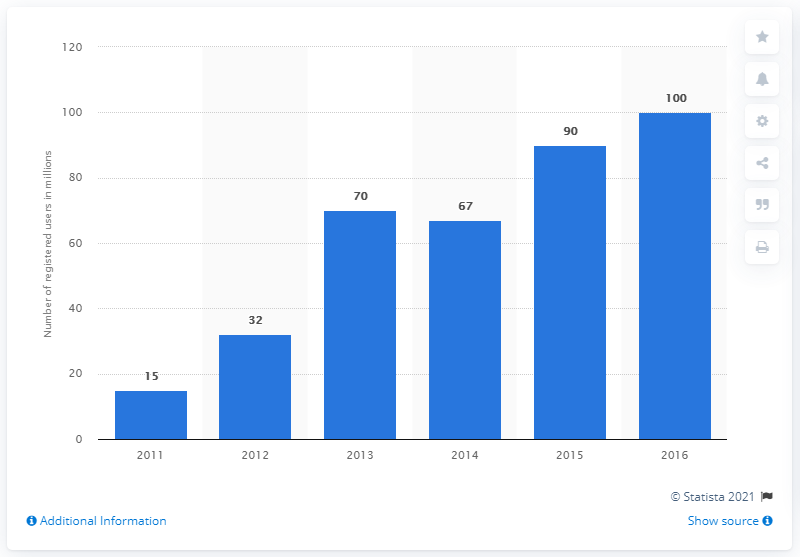Identify some key points in this picture. In 2016, the number of monthly active users of League of Legends was approximately 100 million. In 2015, the number of monthly active users (MAU) for League of Legends was approximately 90 million. 